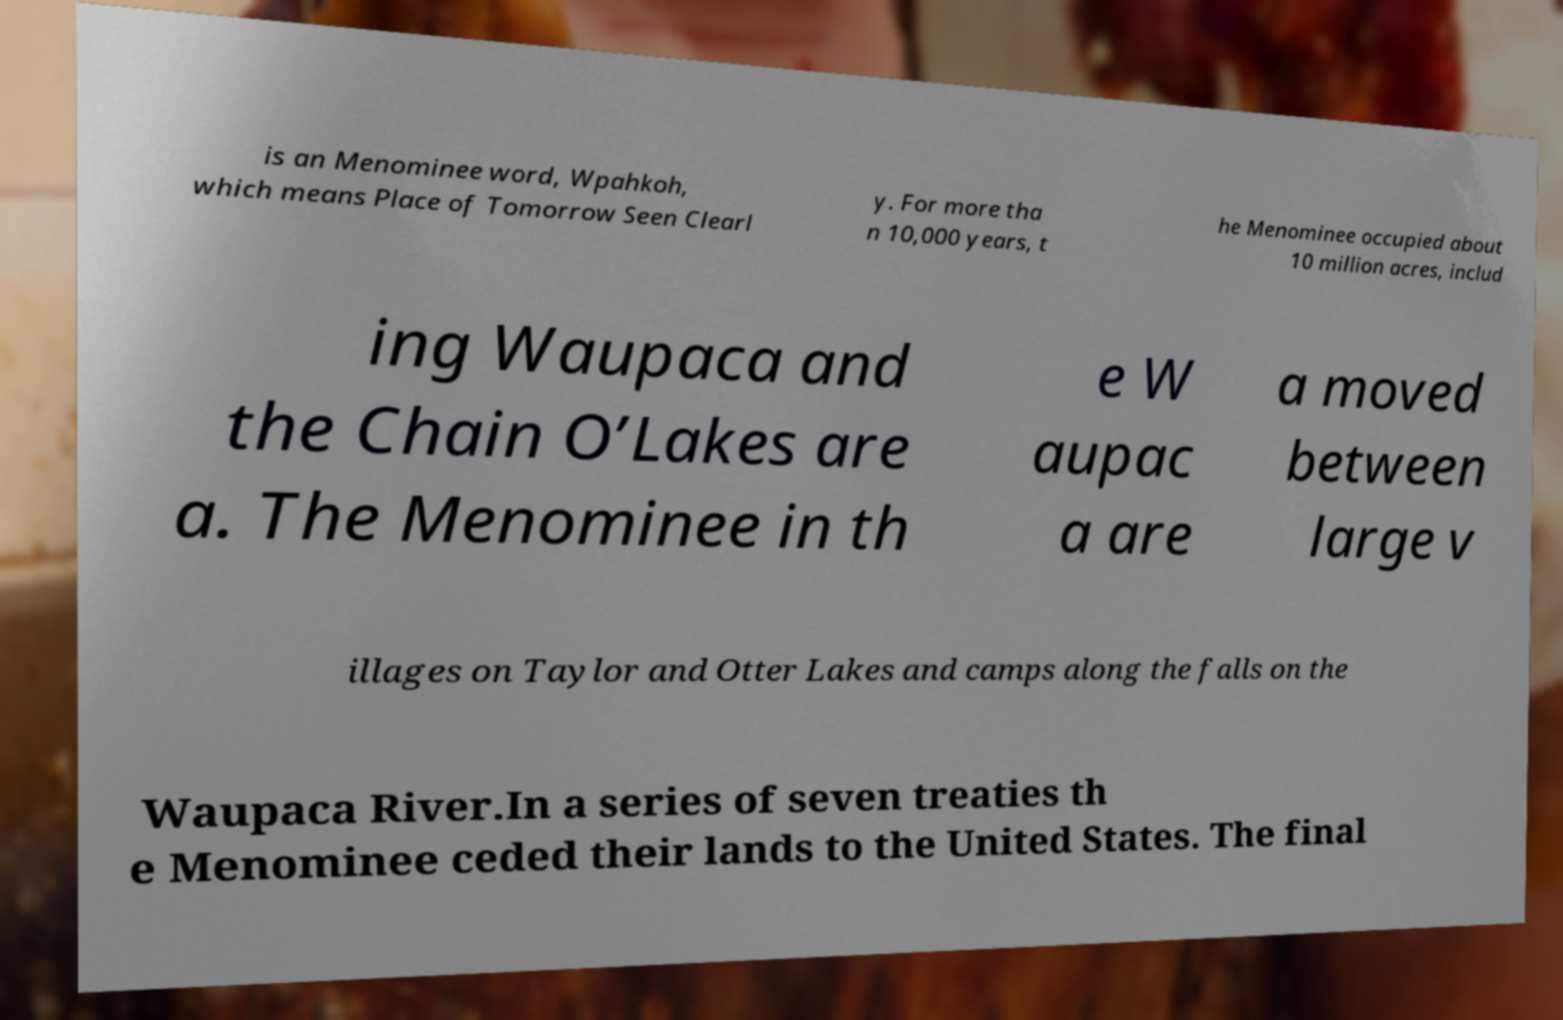Please identify and transcribe the text found in this image. is an Menominee word, Wpahkoh, which means Place of Tomorrow Seen Clearl y. For more tha n 10,000 years, t he Menominee occupied about 10 million acres, includ ing Waupaca and the Chain O’Lakes are a. The Menominee in th e W aupac a are a moved between large v illages on Taylor and Otter Lakes and camps along the falls on the Waupaca River.In a series of seven treaties th e Menominee ceded their lands to the United States. The final 